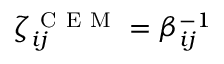<formula> <loc_0><loc_0><loc_500><loc_500>\zeta _ { i j } ^ { C E M } = \beta _ { i j } ^ { - 1 }</formula> 